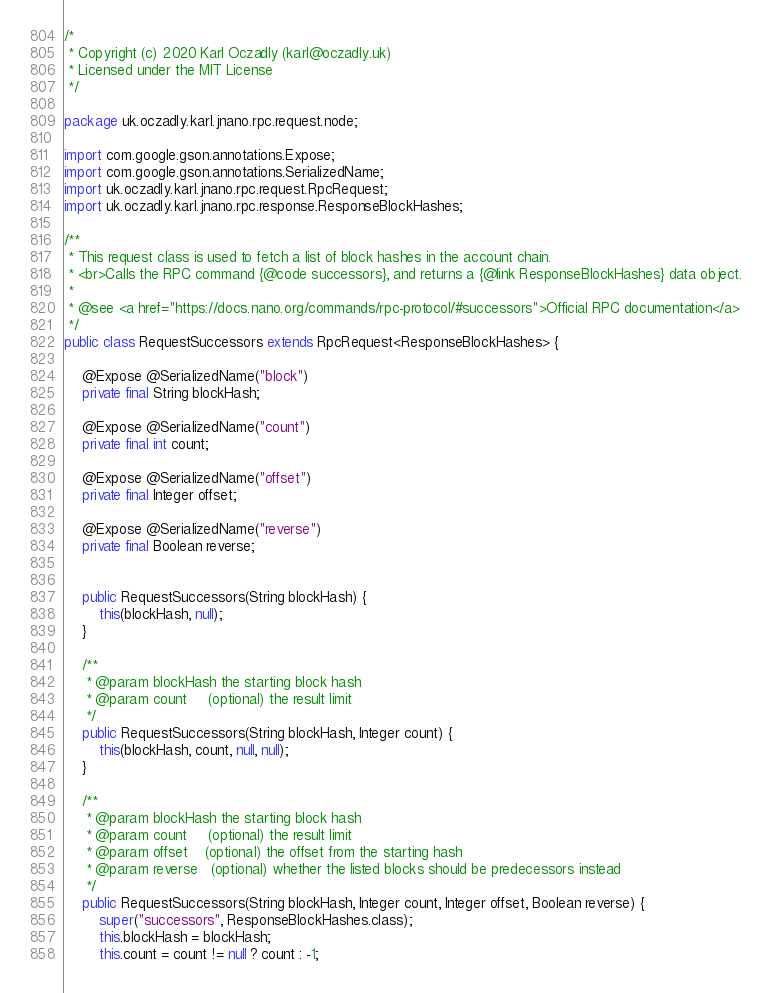<code> <loc_0><loc_0><loc_500><loc_500><_Java_>/*
 * Copyright (c) 2020 Karl Oczadly (karl@oczadly.uk)
 * Licensed under the MIT License
 */

package uk.oczadly.karl.jnano.rpc.request.node;

import com.google.gson.annotations.Expose;
import com.google.gson.annotations.SerializedName;
import uk.oczadly.karl.jnano.rpc.request.RpcRequest;
import uk.oczadly.karl.jnano.rpc.response.ResponseBlockHashes;

/**
 * This request class is used to fetch a list of block hashes in the account chain.
 * <br>Calls the RPC command {@code successors}, and returns a {@link ResponseBlockHashes} data object.
 *
 * @see <a href="https://docs.nano.org/commands/rpc-protocol/#successors">Official RPC documentation</a>
 */
public class RequestSuccessors extends RpcRequest<ResponseBlockHashes> {
    
    @Expose @SerializedName("block")
    private final String blockHash;
    
    @Expose @SerializedName("count")
    private final int count;
    
    @Expose @SerializedName("offset")
    private final Integer offset;
    
    @Expose @SerializedName("reverse")
    private final Boolean reverse;
    
    
    public RequestSuccessors(String blockHash) {
        this(blockHash, null);
    }
    
    /**
     * @param blockHash the starting block hash
     * @param count     (optional) the result limit
     */
    public RequestSuccessors(String blockHash, Integer count) {
        this(blockHash, count, null, null);
    }
    
    /**
     * @param blockHash the starting block hash
     * @param count     (optional) the result limit
     * @param offset    (optional) the offset from the starting hash
     * @param reverse   (optional) whether the listed blocks should be predecessors instead
     */
    public RequestSuccessors(String blockHash, Integer count, Integer offset, Boolean reverse) {
        super("successors", ResponseBlockHashes.class);
        this.blockHash = blockHash;
        this.count = count != null ? count : -1;</code> 